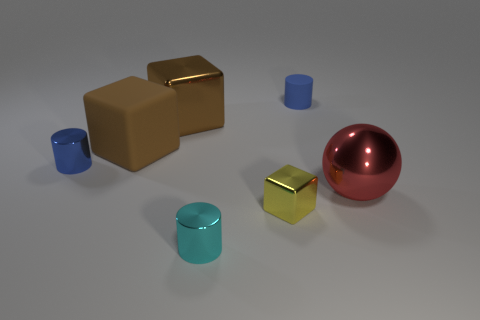There is a cylinder that is to the right of the small cyan shiny thing; what size is it?
Offer a very short reply. Small. The large red metallic object has what shape?
Your answer should be compact. Sphere. There is a metallic block behind the big red metal thing; does it have the same size as the rubber object that is on the right side of the tiny cyan metallic cylinder?
Provide a short and direct response. No. What is the size of the blue thing to the right of the big metal object that is behind the tiny metallic cylinder that is behind the shiny sphere?
Offer a very short reply. Small. There is a tiny shiny object that is on the right side of the cylinder that is in front of the large metallic object right of the rubber cylinder; what shape is it?
Your answer should be very brief. Cube. What is the shape of the tiny shiny thing that is behind the big red metallic object?
Your answer should be very brief. Cylinder. Is the material of the small block the same as the cylinder that is left of the rubber cube?
Provide a succinct answer. Yes. What number of other objects are the same shape as the large red object?
Offer a terse response. 0. There is a big shiny block; is it the same color as the big object right of the yellow object?
Offer a very short reply. No. Is there anything else that has the same material as the big red object?
Provide a short and direct response. Yes. 